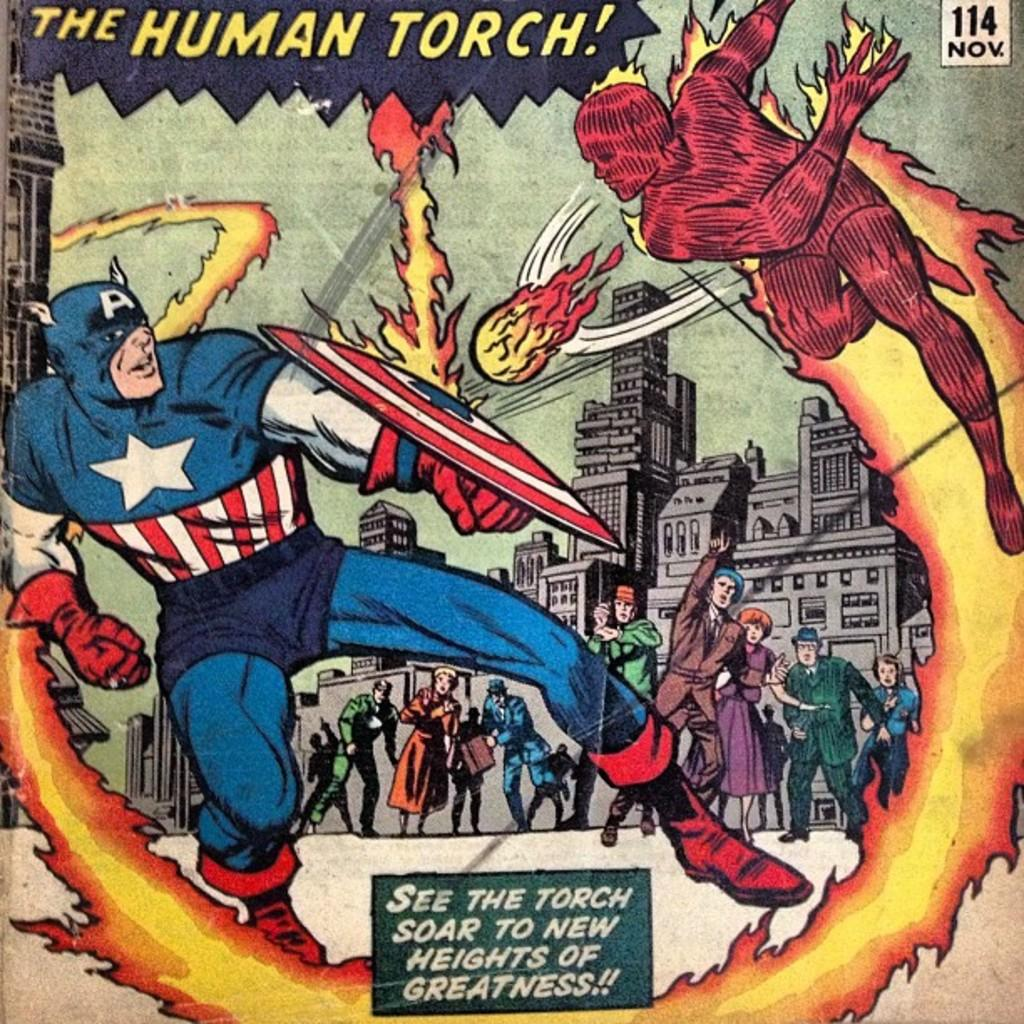Provide a one-sentence caption for the provided image. The cover of a DC comic featuring captain america fighting the huiman torch as crowds look on. 